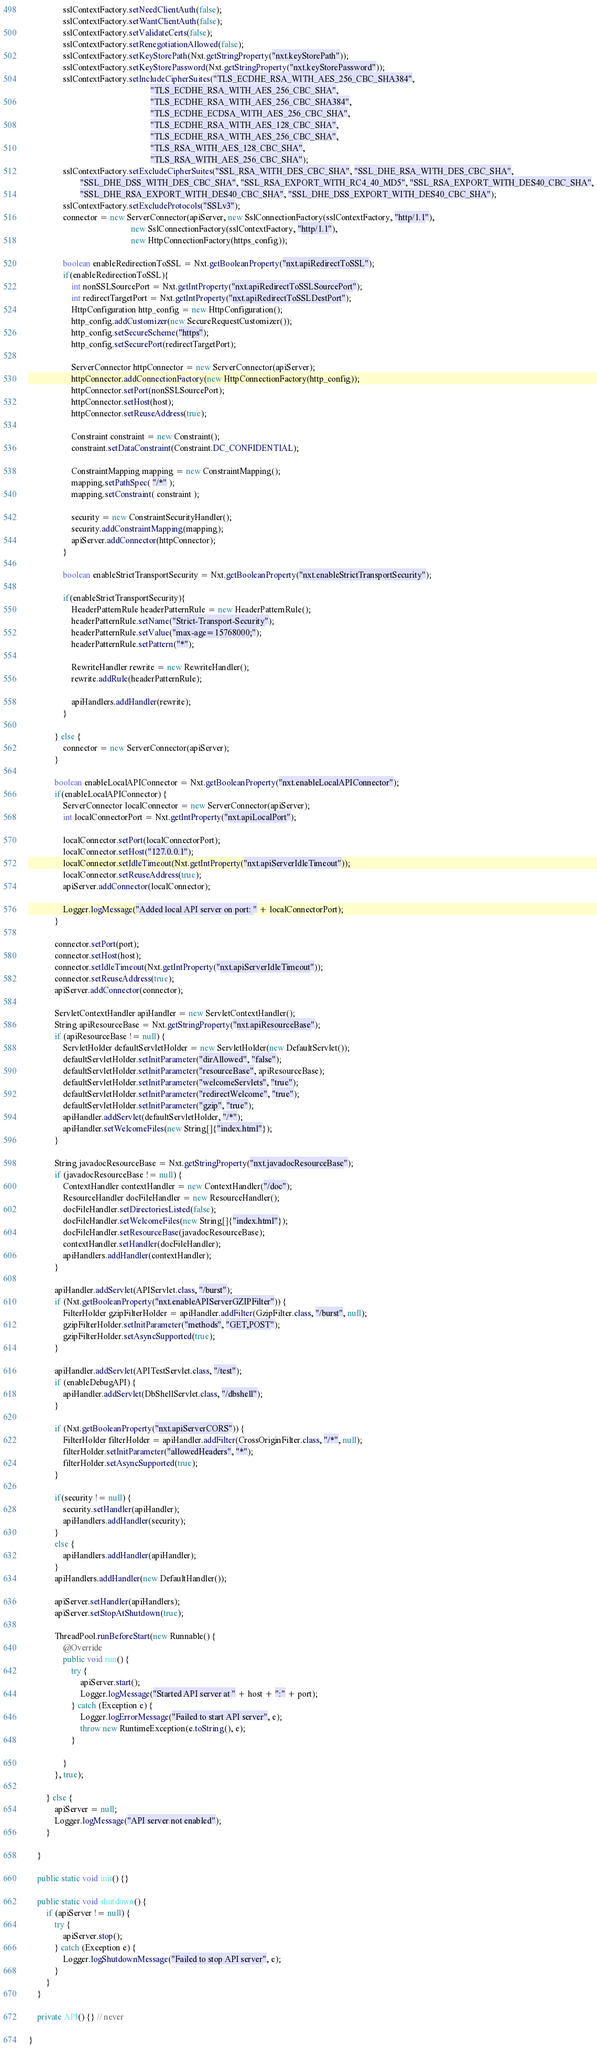Convert code to text. <code><loc_0><loc_0><loc_500><loc_500><_Java_>                sslContextFactory.setNeedClientAuth(false);
                sslContextFactory.setWantClientAuth(false);
                sslContextFactory.setValidateCerts(false);
                sslContextFactory.setRenegotiationAllowed(false);
                sslContextFactory.setKeyStorePath(Nxt.getStringProperty("nxt.keyStorePath"));
                sslContextFactory.setKeyStorePassword(Nxt.getStringProperty("nxt.keyStorePassword"));
                sslContextFactory.setIncludeCipherSuites("TLS_ECDHE_RSA_WITH_AES_256_CBC_SHA384",
                                                         "TLS_ECDHE_RSA_WITH_AES_256_CBC_SHA",
                                                         "TLS_ECDHE_RSA_WITH_AES_256_CBC_SHA384",
                                                         "TLS_ECDHE_ECDSA_WITH_AES_256_CBC_SHA",
                                                         "TLS_ECDHE_RSA_WITH_AES_128_CBC_SHA",
                                                         "TLS_ECDHE_RSA_WITH_AES_256_CBC_SHA",
                                                         "TLS_RSA_WITH_AES_128_CBC_SHA",
                                                         "TLS_RSA_WITH_AES_256_CBC_SHA");
                sslContextFactory.setExcludeCipherSuites("SSL_RSA_WITH_DES_CBC_SHA", "SSL_DHE_RSA_WITH_DES_CBC_SHA",
                        "SSL_DHE_DSS_WITH_DES_CBC_SHA", "SSL_RSA_EXPORT_WITH_RC4_40_MD5", "SSL_RSA_EXPORT_WITH_DES40_CBC_SHA",
                        "SSL_DHE_RSA_EXPORT_WITH_DES40_CBC_SHA", "SSL_DHE_DSS_EXPORT_WITH_DES40_CBC_SHA");
                sslContextFactory.setExcludeProtocols("SSLv3");
                connector = new ServerConnector(apiServer, new SslConnectionFactory(sslContextFactory, "http/1.1"),
                                                new SslConnectionFactory(sslContextFactory, "http/1.1"),
                                                new HttpConnectionFactory(https_config));
                
                boolean enableRedirectionToSSL = Nxt.getBooleanProperty("nxt.apiRedirectToSSL");
                if(enableRedirectionToSSL){
                    int nonSSLSourcePort = Nxt.getIntProperty("nxt.apiRedirectToSSLSourcePort");
                    int redirectTargetPort = Nxt.getIntProperty("nxt.apiRedirectToSSLDestPort");
                    HttpConfiguration http_config = new HttpConfiguration();
                    http_config.addCustomizer(new SecureRequestCustomizer());
                    http_config.setSecureScheme("https");
                    http_config.setSecurePort(redirectTargetPort);
                    
                    ServerConnector httpConnector = new ServerConnector(apiServer);
                    httpConnector.addConnectionFactory(new HttpConnectionFactory(http_config));
                    httpConnector.setPort(nonSSLSourcePort);
                    httpConnector.setHost(host);
                    httpConnector.setReuseAddress(true);
                    
                    Constraint constraint = new Constraint();
                    constraint.setDataConstraint(Constraint.DC_CONFIDENTIAL);
                    
                    ConstraintMapping mapping = new ConstraintMapping();
                    mapping.setPathSpec( "/*" );
                    mapping.setConstraint( constraint );
                    
                    security = new ConstraintSecurityHandler();
                    security.addConstraintMapping(mapping);
                    apiServer.addConnector(httpConnector);
                }
                
                boolean enableStrictTransportSecurity = Nxt.getBooleanProperty("nxt.enableStrictTransportSecurity");
                
                if(enableStrictTransportSecurity){
                    HeaderPatternRule headerPatternRule = new HeaderPatternRule();
                    headerPatternRule.setName("Strict-Transport-Security");
                    headerPatternRule.setValue("max-age=15768000;");
                    headerPatternRule.setPattern("*");
                    
                    RewriteHandler rewrite = new RewriteHandler();
                    rewrite.addRule(headerPatternRule);
                    
                    apiHandlers.addHandler(rewrite);
                }
                
            } else {
                connector = new ServerConnector(apiServer);
            }
            
            boolean enableLocalAPIConnector = Nxt.getBooleanProperty("nxt.enableLocalAPIConnector");
            if(enableLocalAPIConnector) {
                ServerConnector localConnector = new ServerConnector(apiServer);
                int localConnectorPort = Nxt.getIntProperty("nxt.apiLocalPort");
                
                localConnector.setPort(localConnectorPort);
                localConnector.setHost("127.0.0.1");
                localConnector.setIdleTimeout(Nxt.getIntProperty("nxt.apiServerIdleTimeout"));
                localConnector.setReuseAddress(true);
                apiServer.addConnector(localConnector);
                
                Logger.logMessage("Added local API server on port: " + localConnectorPort);
            }

            connector.setPort(port);
            connector.setHost(host);
            connector.setIdleTimeout(Nxt.getIntProperty("nxt.apiServerIdleTimeout"));
            connector.setReuseAddress(true);
            apiServer.addConnector(connector);

            ServletContextHandler apiHandler = new ServletContextHandler();
            String apiResourceBase = Nxt.getStringProperty("nxt.apiResourceBase");
            if (apiResourceBase != null) {
                ServletHolder defaultServletHolder = new ServletHolder(new DefaultServlet());
                defaultServletHolder.setInitParameter("dirAllowed", "false");
                defaultServletHolder.setInitParameter("resourceBase", apiResourceBase);
                defaultServletHolder.setInitParameter("welcomeServlets", "true");
                defaultServletHolder.setInitParameter("redirectWelcome", "true");
                defaultServletHolder.setInitParameter("gzip", "true");
                apiHandler.addServlet(defaultServletHolder, "/*");
                apiHandler.setWelcomeFiles(new String[]{"index.html"});
            }

            String javadocResourceBase = Nxt.getStringProperty("nxt.javadocResourceBase");
            if (javadocResourceBase != null) {
                ContextHandler contextHandler = new ContextHandler("/doc");
                ResourceHandler docFileHandler = new ResourceHandler();
                docFileHandler.setDirectoriesListed(false);
                docFileHandler.setWelcomeFiles(new String[]{"index.html"});
                docFileHandler.setResourceBase(javadocResourceBase);
                contextHandler.setHandler(docFileHandler);
                apiHandlers.addHandler(contextHandler);
            }

            apiHandler.addServlet(APIServlet.class, "/burst");
            if (Nxt.getBooleanProperty("nxt.enableAPIServerGZIPFilter")) {
                FilterHolder gzipFilterHolder = apiHandler.addFilter(GzipFilter.class, "/burst", null);
                gzipFilterHolder.setInitParameter("methods", "GET,POST");
                gzipFilterHolder.setAsyncSupported(true);
            }

            apiHandler.addServlet(APITestServlet.class, "/test");
            if (enableDebugAPI) {
                apiHandler.addServlet(DbShellServlet.class, "/dbshell");
            }

            if (Nxt.getBooleanProperty("nxt.apiServerCORS")) {
                FilterHolder filterHolder = apiHandler.addFilter(CrossOriginFilter.class, "/*", null);
                filterHolder.setInitParameter("allowedHeaders", "*");
                filterHolder.setAsyncSupported(true);
            }

            if(security != null) {
                security.setHandler(apiHandler);
                apiHandlers.addHandler(security);
            }
            else {
                apiHandlers.addHandler(apiHandler);
            }
            apiHandlers.addHandler(new DefaultHandler());

            apiServer.setHandler(apiHandlers);
            apiServer.setStopAtShutdown(true);

            ThreadPool.runBeforeStart(new Runnable() {
                @Override
                public void run() {
                    try {
                        apiServer.start();
                        Logger.logMessage("Started API server at " + host + ":" + port);
                    } catch (Exception e) {
                        Logger.logErrorMessage("Failed to start API server", e);
                        throw new RuntimeException(e.toString(), e);
                    }

                }
            }, true);

        } else {
            apiServer = null;
            Logger.logMessage("API server not enabled");
        }

    }

    public static void init() {}

    public static void shutdown() {
        if (apiServer != null) {
            try {
                apiServer.stop();
            } catch (Exception e) {
                Logger.logShutdownMessage("Failed to stop API server", e);
            }
        }
    }

    private API() {} // never

}
</code> 